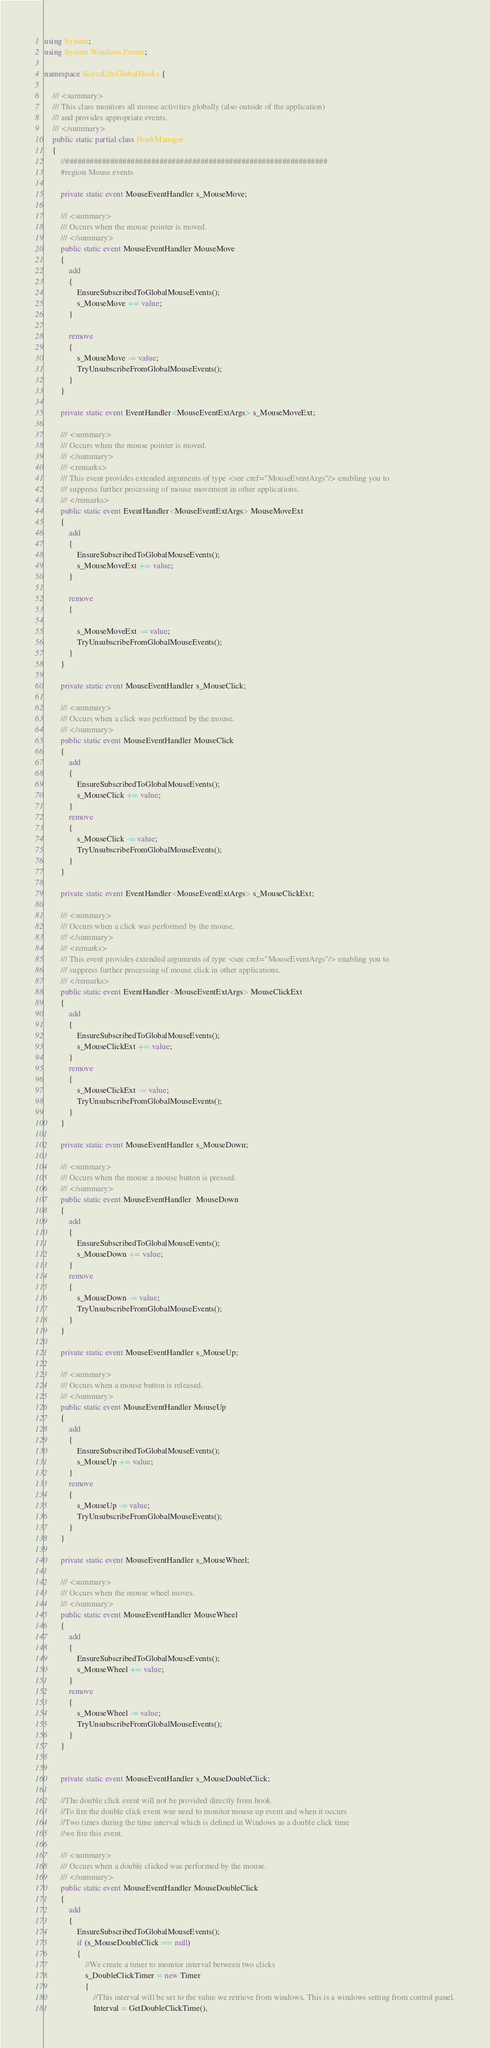Convert code to text. <code><loc_0><loc_0><loc_500><loc_500><_C#_>using System;
using System.Windows.Forms;

namespace SierraLib.GlobalHooks {

    /// <summary>
    /// This class monitors all mouse activities globally (also outside of the application) 
    /// and provides appropriate events.
    /// </summary>
    public static partial class HookManager
    {
        //################################################################
        #region Mouse events

        private static event MouseEventHandler s_MouseMove;

        /// <summary>
        /// Occurs when the mouse pointer is moved. 
        /// </summary>
        public static event MouseEventHandler MouseMove
        {
            add
            {
                EnsureSubscribedToGlobalMouseEvents();
                s_MouseMove += value;
            }

            remove
            {
                s_MouseMove -= value;
                TryUnsubscribeFromGlobalMouseEvents();
            }
        }

        private static event EventHandler<MouseEventExtArgs> s_MouseMoveExt;

        /// <summary>
        /// Occurs when the mouse pointer is moved. 
        /// </summary>
        /// <remarks>
        /// This event provides extended arguments of type <see cref="MouseEventArgs"/> enabling you to 
        /// suppress further processing of mouse movement in other applications.
        /// </remarks>
        public static event EventHandler<MouseEventExtArgs> MouseMoveExt
        {
            add
            {
                EnsureSubscribedToGlobalMouseEvents();
                s_MouseMoveExt += value;
            }

            remove
            {

                s_MouseMoveExt -= value;
                TryUnsubscribeFromGlobalMouseEvents();
            }
        }

        private static event MouseEventHandler s_MouseClick;

        /// <summary>
        /// Occurs when a click was performed by the mouse. 
        /// </summary>
        public static event MouseEventHandler MouseClick
        {
            add
            {
                EnsureSubscribedToGlobalMouseEvents();
                s_MouseClick += value;
            }
            remove
            {
                s_MouseClick -= value;
                TryUnsubscribeFromGlobalMouseEvents();
            }
        }

        private static event EventHandler<MouseEventExtArgs> s_MouseClickExt;

        /// <summary>
        /// Occurs when a click was performed by the mouse. 
        /// </summary>
        /// <remarks>
        /// This event provides extended arguments of type <see cref="MouseEventArgs"/> enabling you to 
        /// suppress further processing of mouse click in other applications.
        /// </remarks>
        public static event EventHandler<MouseEventExtArgs> MouseClickExt
        {
            add
            {
                EnsureSubscribedToGlobalMouseEvents();
                s_MouseClickExt += value;
            }
            remove
            {
                s_MouseClickExt -= value;
                TryUnsubscribeFromGlobalMouseEvents();
            }
        }

        private static event MouseEventHandler s_MouseDown;

        /// <summary>
        /// Occurs when the mouse a mouse button is pressed. 
        /// </summary>
        public static event MouseEventHandler  MouseDown
        {
            add 
            { 
                EnsureSubscribedToGlobalMouseEvents();
                s_MouseDown += value;
            }
            remove
            {
                s_MouseDown -= value;
                TryUnsubscribeFromGlobalMouseEvents();
            }
        }

        private static event MouseEventHandler s_MouseUp;

        /// <summary>
        /// Occurs when a mouse button is released. 
        /// </summary>
        public static event MouseEventHandler MouseUp
        {
            add
            {
                EnsureSubscribedToGlobalMouseEvents();
                s_MouseUp += value;
            }
            remove
            {
                s_MouseUp -= value;
                TryUnsubscribeFromGlobalMouseEvents();
            }
        }

        private static event MouseEventHandler s_MouseWheel;

        /// <summary>
        /// Occurs when the mouse wheel moves. 
        /// </summary>
        public static event MouseEventHandler MouseWheel
        {
            add
            {
                EnsureSubscribedToGlobalMouseEvents();
                s_MouseWheel += value;
            }
            remove
            {
                s_MouseWheel -= value;
                TryUnsubscribeFromGlobalMouseEvents();
            }
        }


        private static event MouseEventHandler s_MouseDoubleClick;

        //The double click event will not be provided directly from hook.
        //To fire the double click event wee need to monitor mouse up event and when it occurs 
        //Two times during the time interval which is defined in Windows as a double click time
        //we fire this event.

        /// <summary>
        /// Occurs when a double clicked was performed by the mouse. 
        /// </summary>
        public static event MouseEventHandler MouseDoubleClick
        {
            add
            {
                EnsureSubscribedToGlobalMouseEvents();
                if (s_MouseDoubleClick == null)
                {
                    //We create a timer to monitor interval between two clicks
                    s_DoubleClickTimer = new Timer
                    {
                        //This interval will be set to the value we retrieve from windows. This is a windows setting from control panel.
                        Interval = GetDoubleClickTime(),</code> 